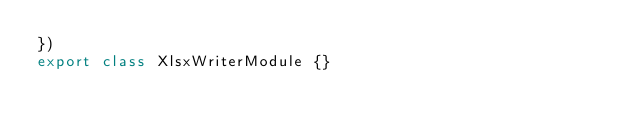Convert code to text. <code><loc_0><loc_0><loc_500><loc_500><_TypeScript_>})
export class XlsxWriterModule {}
</code> 